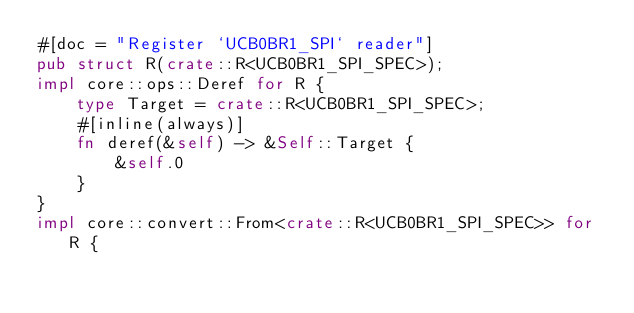<code> <loc_0><loc_0><loc_500><loc_500><_Rust_>#[doc = "Register `UCB0BR1_SPI` reader"]
pub struct R(crate::R<UCB0BR1_SPI_SPEC>);
impl core::ops::Deref for R {
    type Target = crate::R<UCB0BR1_SPI_SPEC>;
    #[inline(always)]
    fn deref(&self) -> &Self::Target {
        &self.0
    }
}
impl core::convert::From<crate::R<UCB0BR1_SPI_SPEC>> for R {</code> 